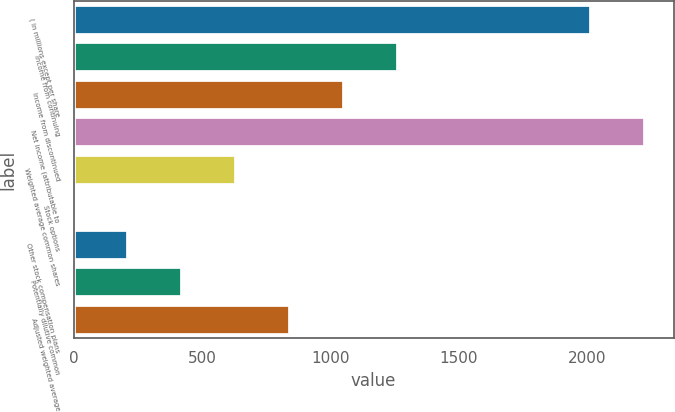Convert chart. <chart><loc_0><loc_0><loc_500><loc_500><bar_chart><fcel>( in millions except per share<fcel>Income from continuing<fcel>Income from discontinued<fcel>Net income (attributable to<fcel>Weighted average common shares<fcel>Stock options<fcel>Other stock compensation plans<fcel>Potentially dilutive common<fcel>Adjusted weighted average<nl><fcel>2014<fcel>1261.76<fcel>1051.7<fcel>2224.06<fcel>631.58<fcel>1.4<fcel>211.46<fcel>421.52<fcel>841.64<nl></chart> 